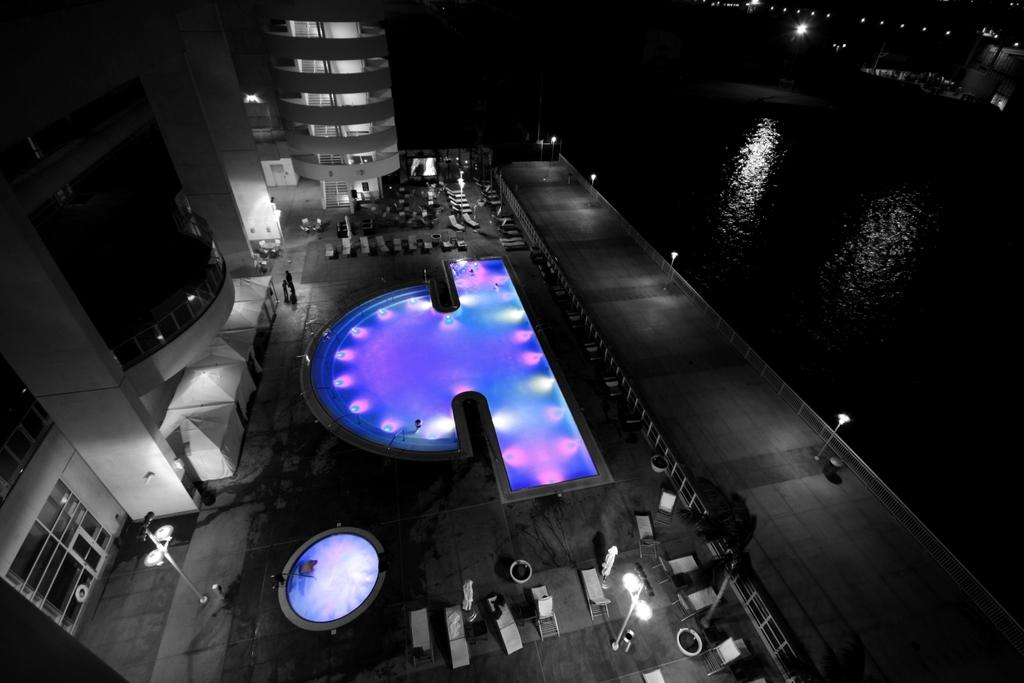What type of structure is visible in the image? There is a building in the image. What type of furniture is present in the image? There are chairs in the image. What type of illumination is visible in the image? There are lights in the image. What type of surface is present for people to sit or place objects on? There are tables in the image. What type of pathway is visible in the image? There is a road in the image. What type of vegetation is visible in the image? There are trees in the image. What type of pollution is visible in the image? There is no visible pollution in the image. What type of skin condition is visible on the trees in the image? There is no mention of any skin condition on the trees in the image. 